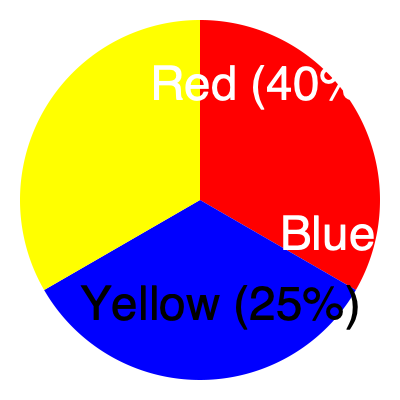In your latest music video, you've used color psychology to evoke specific emotions. The pie chart represents the distribution of dominant colors in key scenes. Given that red often symbolizes passion and energy, blue represents calmness and trust, and yellow signifies happiness and optimism, what emotional journey are you likely conveying to your fans through this color distribution? To analyze the emotional journey conveyed through color psychology in the music video, we need to consider the following steps:

1. Interpret the color distribution:
   - Red: 40%
   - Blue: 35%
   - Yellow: 25%

2. Understand the psychological associations of each color:
   - Red: Passion, energy, excitement
   - Blue: Calmness, trust, stability
   - Yellow: Happiness, optimism, cheerfulness

3. Analyze the proportions and their implications:
   - Red has the largest share, suggesting a strong emphasis on passion and energy
   - Blue follows closely, indicating a significant presence of calmness and trust
   - Yellow has the smallest but still notable share, bringing in elements of happiness and optimism

4. Consider the sequence and balance:
   - The dominance of red suggests the video starts or centers around high energy and passion
   - The substantial presence of blue indicates a transition or contrast to moments of calmness and reflection
   - The inclusion of yellow adds a layer of optimism throughout the emotional journey

5. Interpret the overall emotional narrative:
   - The video likely begins with high energy and passionate scenes (red)
   - It then transitions to more calm and trustworthy moments (blue)
   - Throughout, there's an undercurrent of happiness and optimism (yellow)
   - This creates a dynamic emotional journey that engages viewers through various emotional states

Given this analysis, the emotional journey conveyed is likely one of passionate excitement balanced with moments of calm reflection, all underlined by an optimistic tone. This combination can create a compelling and relatable narrative for fans, taking them through a range of emotions that mirror the complexity of real-life experiences and relationships.
Answer: A journey from passion to reflection, underscored by optimism 